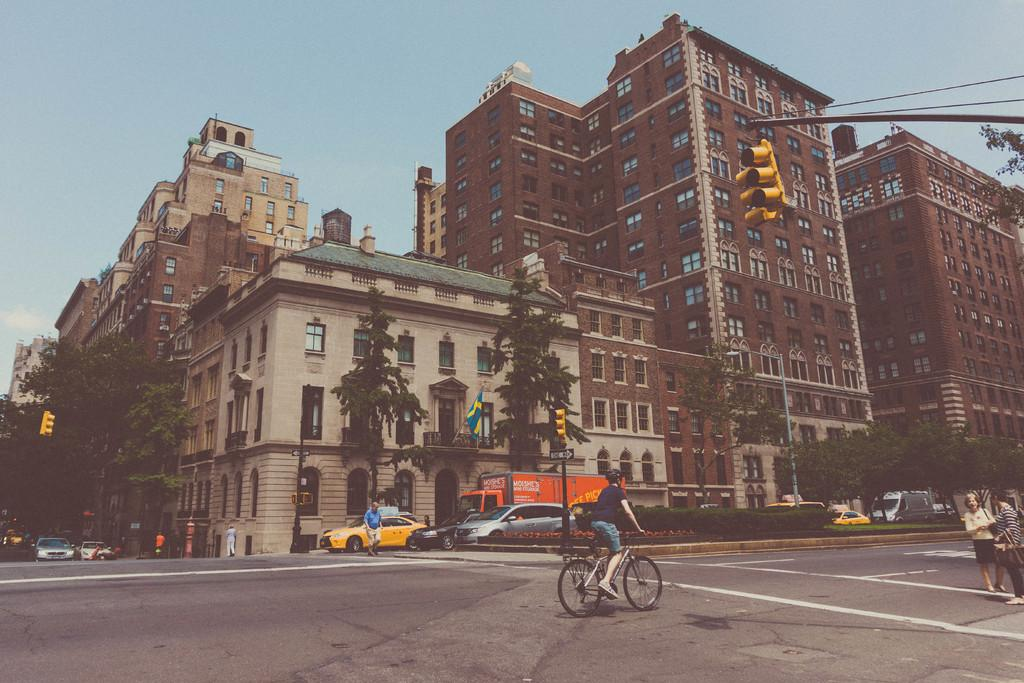What type of vegetation can be seen in the image? There are trees in the image. What type of transportation is visible in the image? There are cars and a bicycle in the image. What is the main feature of the image? There is a road in the image. How many persons can be seen in the image? There are persons in the image. What type of infrastructure is present in the image? There are lights, poles, and a flag in the image. What part of the natural environment is visible in the image? The sky is visible in the image. What type of expert is standing near the flag in the image? There is no expert present in the image; it only features trees, cars, a road, a bicycle, persons, lights, poles, a flag, and the sky. What type of group is gathering around the bicycle in the image? There is no group gathering around the bicycle in the image; it only shows a single bicycle. 